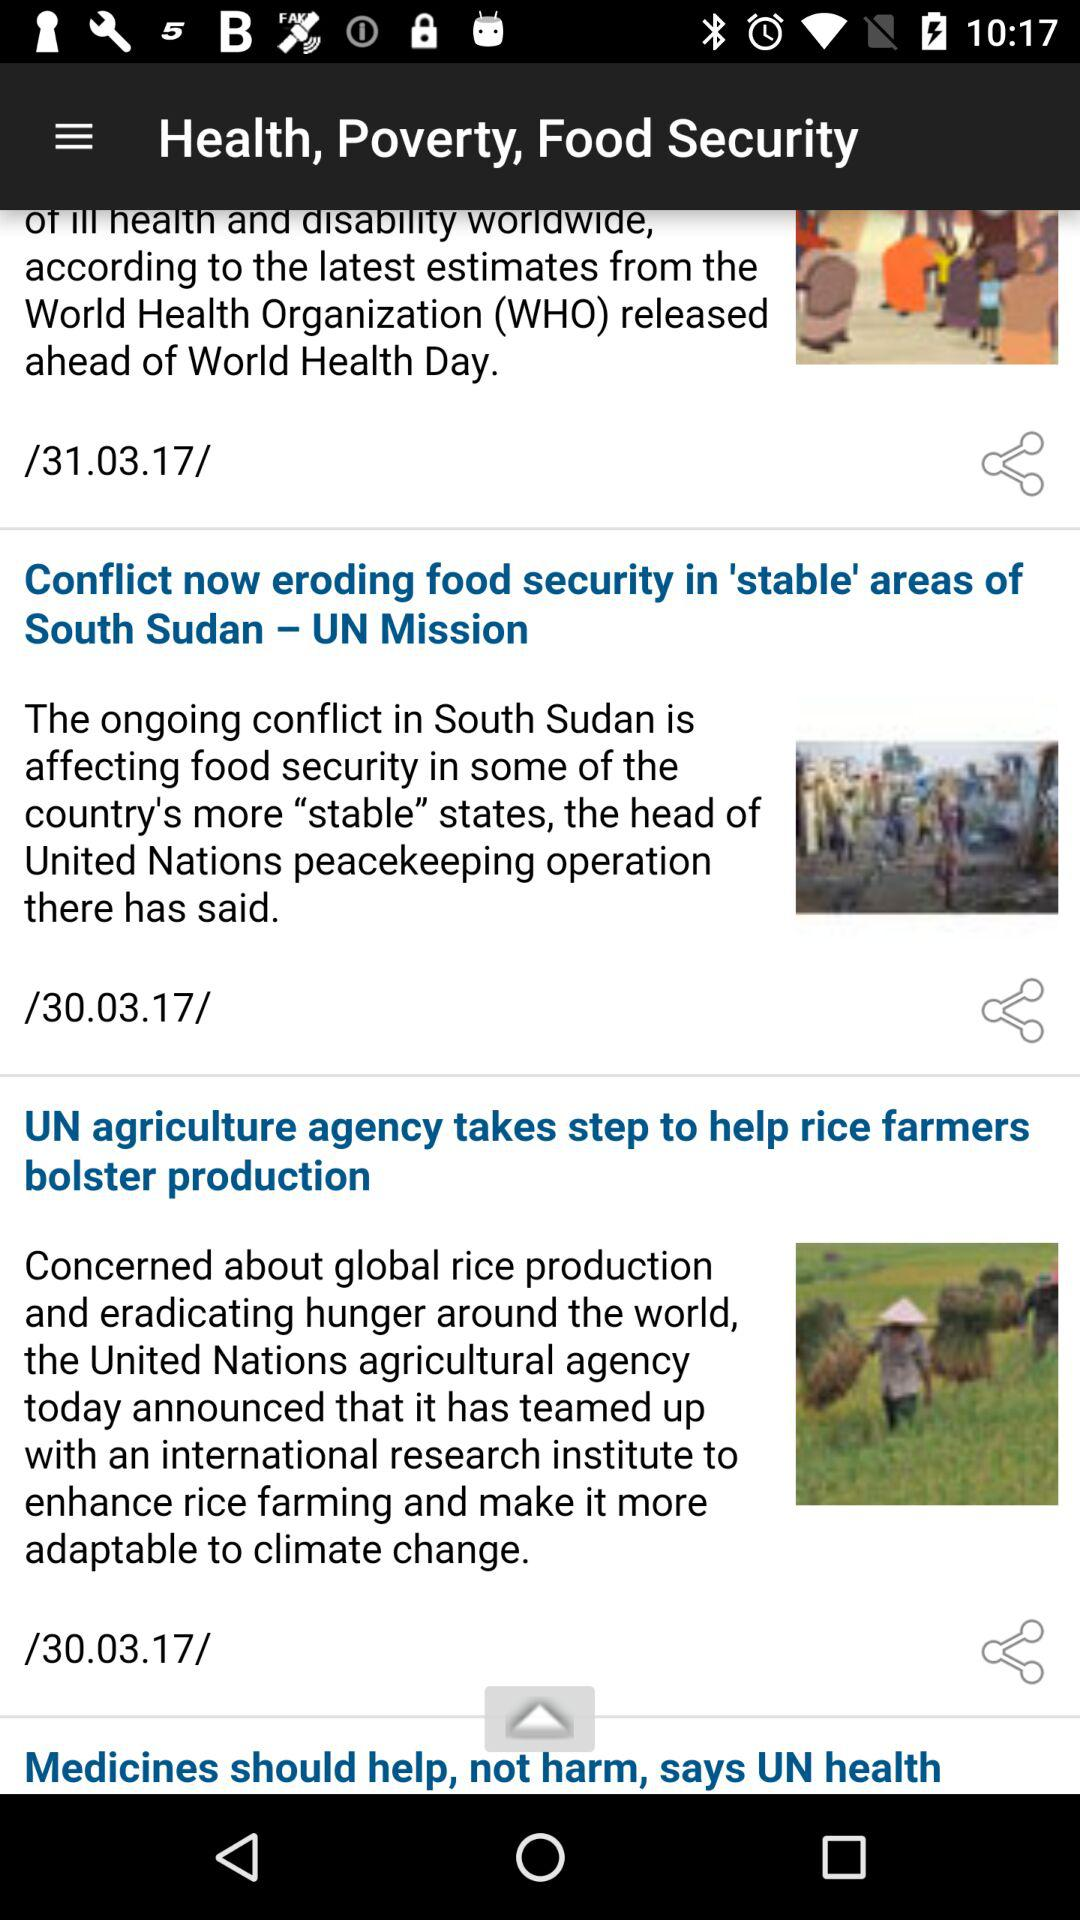What's the published date of "UN agriculture agency takes step to help rice farmers bolster production" article? The published date is March 30, 2017. 